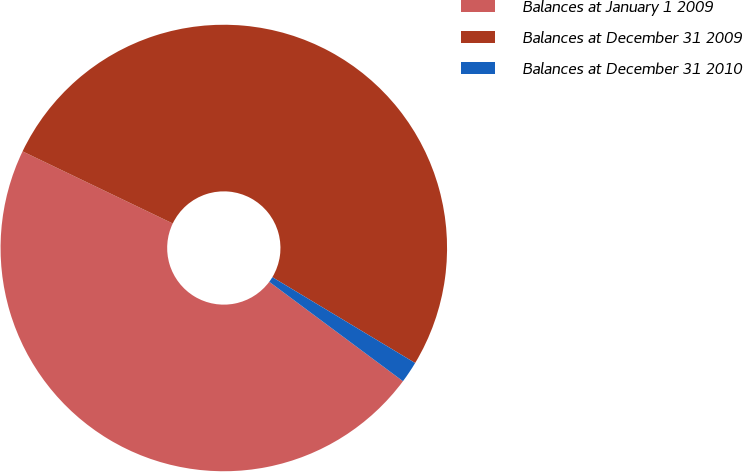<chart> <loc_0><loc_0><loc_500><loc_500><pie_chart><fcel>Balances at January 1 2009<fcel>Balances at December 31 2009<fcel>Balances at December 31 2010<nl><fcel>46.95%<fcel>51.49%<fcel>1.56%<nl></chart> 